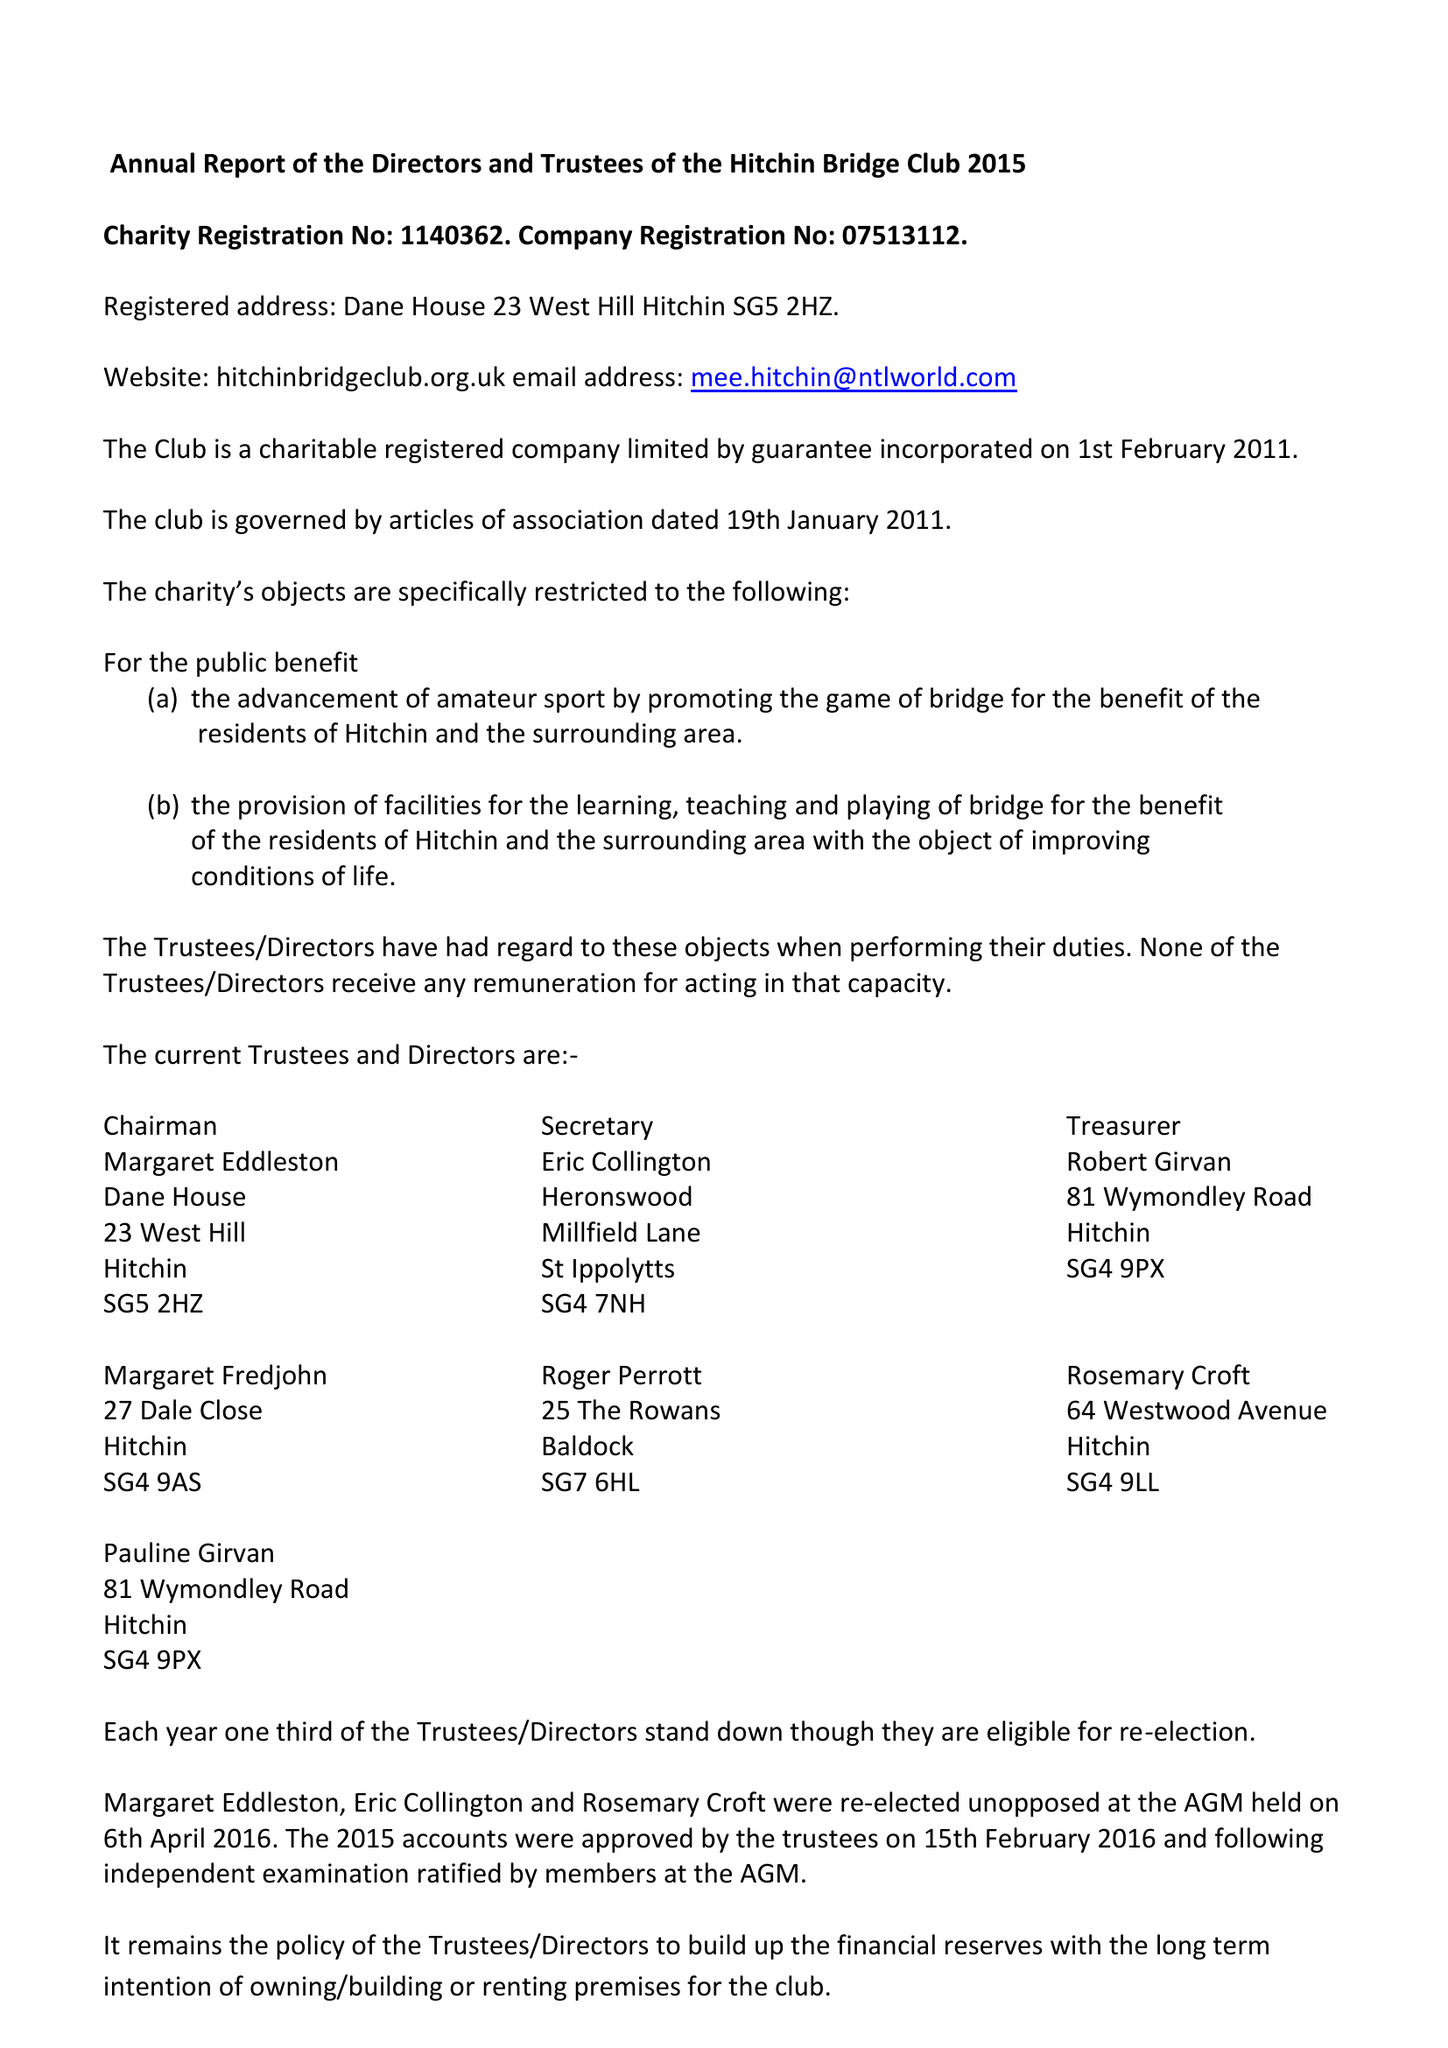What is the value for the spending_annually_in_british_pounds?
Answer the question using a single word or phrase. 16074.00 